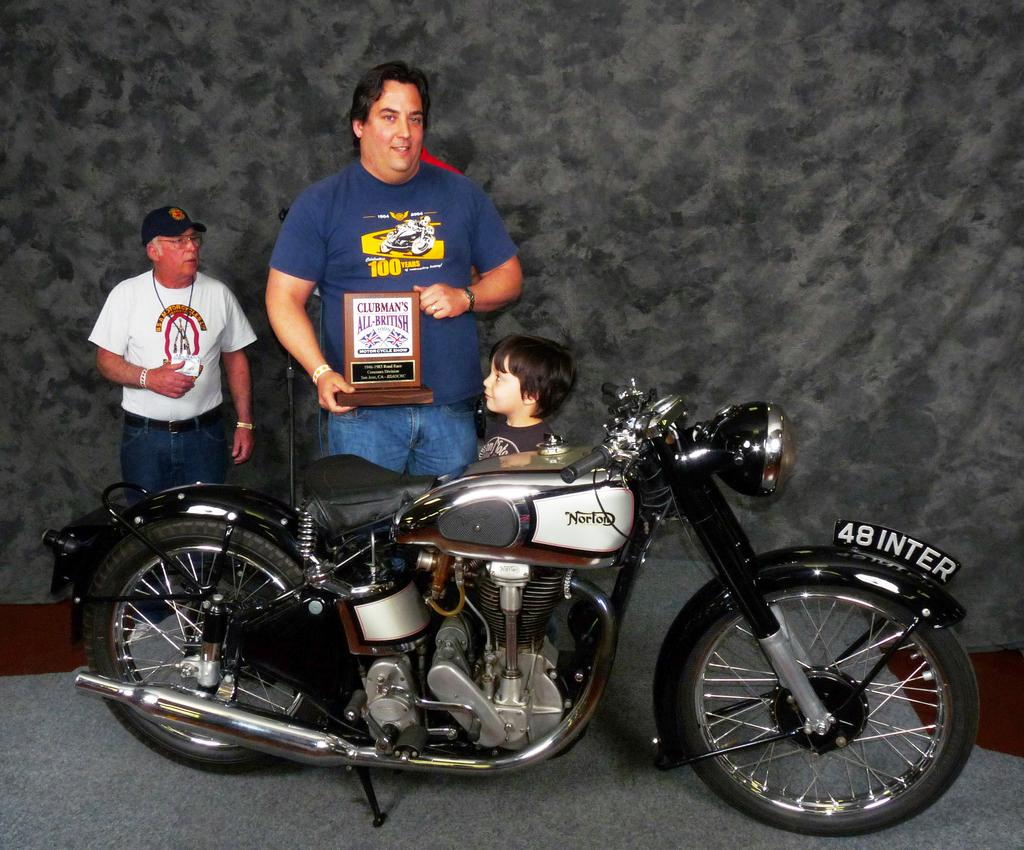How many people are in the image? There are three persons in the image. What are the people doing in the image? The persons are standing in front of a bike. Can you describe the clothing of one of the persons? One person is wearing a blue shirt. What is the person in the blue shirt holding? The person in the blue shirt is holding a memento. Is there a bucket on the hill in the image? There is no bucket or hill present in the image. Can you describe the type of ray that is visible in the image? There are no rays visible in the image. 